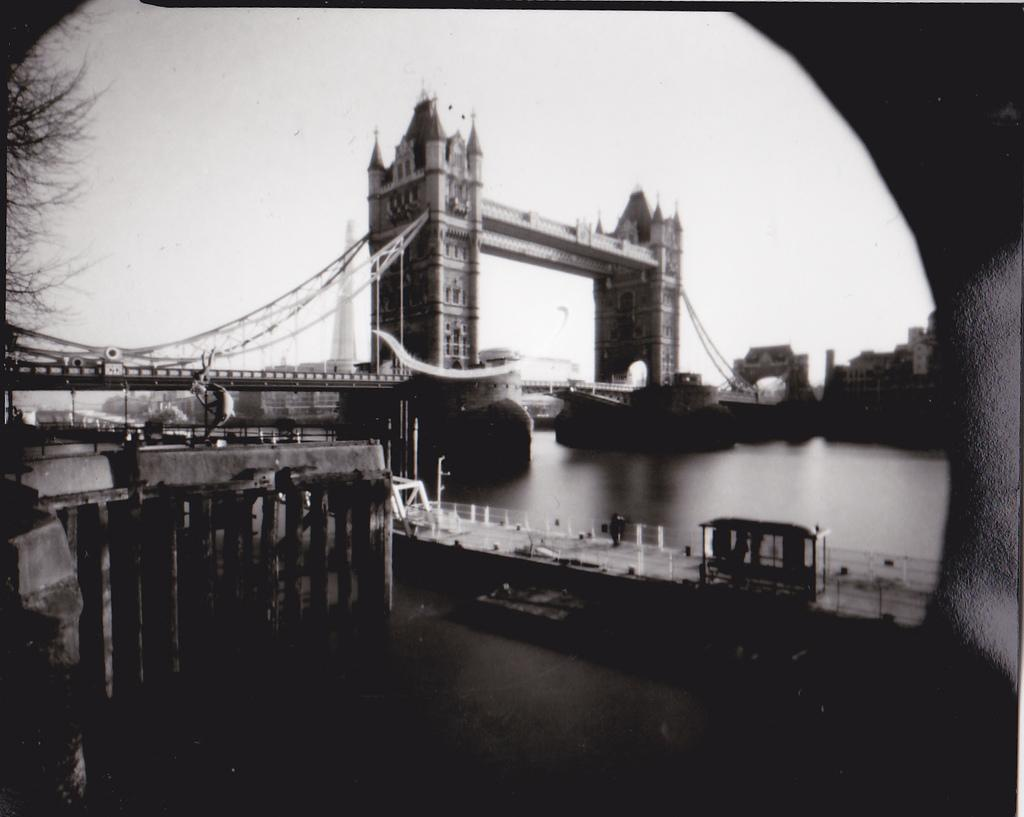What is the color scheme of the image? The image is black and white. What natural feature can be seen in the image? There is a river in the image. What structure is present over the river? There is a bridge over the river. What is visible in the background of the image? The sky is visible in the background of the image. What type of show is taking place in the middle of the river? There is no show or any indication of a performance in the image; it features a river and a bridge. Can you see a ship sailing down the river in the image? There is no ship visible in the image; it only shows a river and a bridge. 